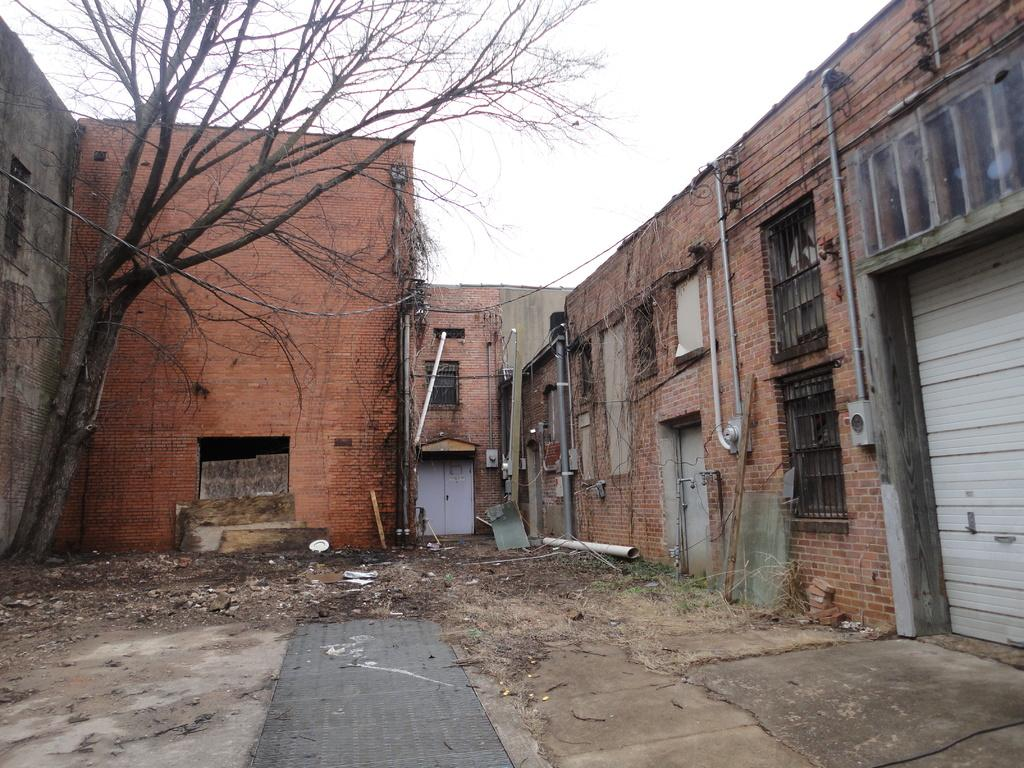What type of natural element can be seen in the image? There is a tree in the image. What type of structures are present in the image? There are buildings with windows in the image. What type of man-made objects can be seen in the image? There are pipes and doors in the image. What is visible in the background of the image? The sky is visible in the background of the image. What type of sand can be seen on the ground in the image? There is no sand visible in the image; it features a tree, buildings, pipes, doors, and the sky. What type of pizzas are being served in the image? There are no pizzas present in the image. 